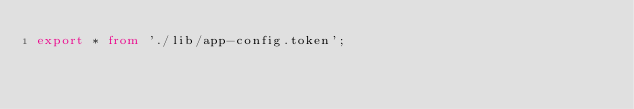<code> <loc_0><loc_0><loc_500><loc_500><_TypeScript_>export * from './lib/app-config.token';
</code> 